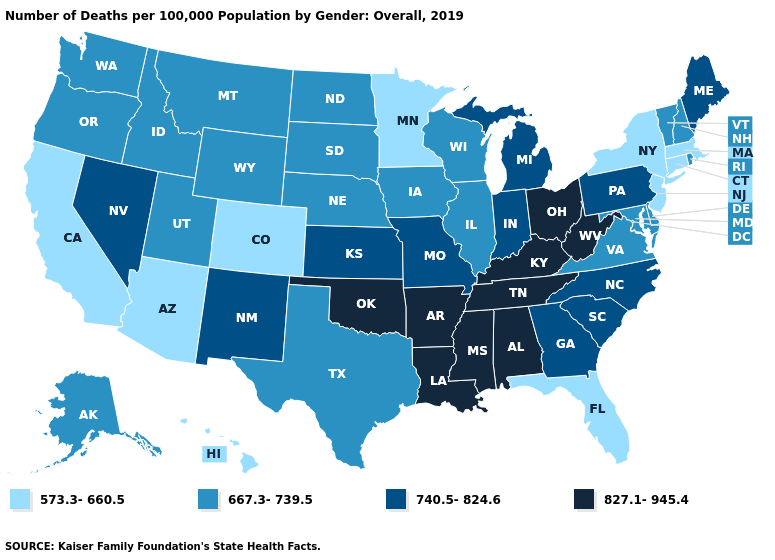Which states have the highest value in the USA?
Quick response, please. Alabama, Arkansas, Kentucky, Louisiana, Mississippi, Ohio, Oklahoma, Tennessee, West Virginia. What is the value of California?
Write a very short answer. 573.3-660.5. What is the highest value in the USA?
Be succinct. 827.1-945.4. Does Maine have the highest value in the Northeast?
Concise answer only. Yes. Among the states that border Georgia , does Florida have the lowest value?
Answer briefly. Yes. What is the value of Alabama?
Be succinct. 827.1-945.4. Does Maine have a higher value than Illinois?
Write a very short answer. Yes. Among the states that border Iowa , does Nebraska have the highest value?
Short answer required. No. Among the states that border New York , does Massachusetts have the highest value?
Give a very brief answer. No. Is the legend a continuous bar?
Keep it brief. No. What is the highest value in states that border Georgia?
Write a very short answer. 827.1-945.4. Name the states that have a value in the range 667.3-739.5?
Give a very brief answer. Alaska, Delaware, Idaho, Illinois, Iowa, Maryland, Montana, Nebraska, New Hampshire, North Dakota, Oregon, Rhode Island, South Dakota, Texas, Utah, Vermont, Virginia, Washington, Wisconsin, Wyoming. Does Illinois have a lower value than New Mexico?
Answer briefly. Yes. What is the value of Maryland?
Give a very brief answer. 667.3-739.5. 